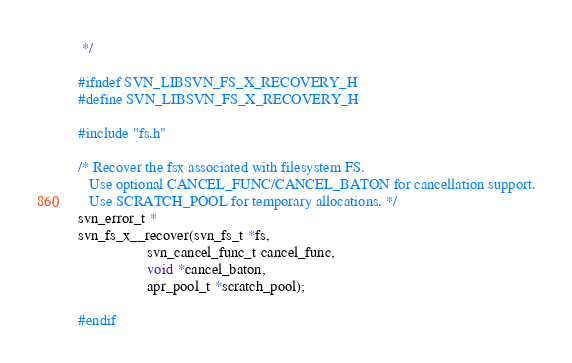Convert code to text. <code><loc_0><loc_0><loc_500><loc_500><_C_> */

#ifndef SVN_LIBSVN_FS_X_RECOVERY_H
#define SVN_LIBSVN_FS_X_RECOVERY_H

#include "fs.h"

/* Recover the fsx associated with filesystem FS.
   Use optional CANCEL_FUNC/CANCEL_BATON for cancellation support.
   Use SCRATCH_POOL for temporary allocations. */
svn_error_t *
svn_fs_x__recover(svn_fs_t *fs,
                  svn_cancel_func_t cancel_func,
                  void *cancel_baton,
                  apr_pool_t *scratch_pool);

#endif
</code> 